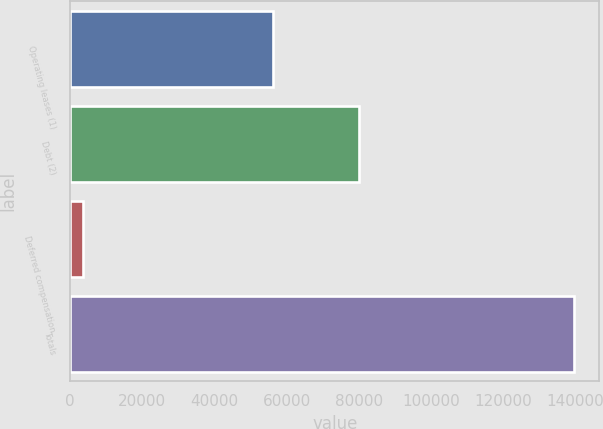Convert chart to OTSL. <chart><loc_0><loc_0><loc_500><loc_500><bar_chart><fcel>Operating leases (1)<fcel>Debt (2)<fcel>Deferred compensation<fcel>Totals<nl><fcel>56100<fcel>80000<fcel>3600<fcel>139700<nl></chart> 